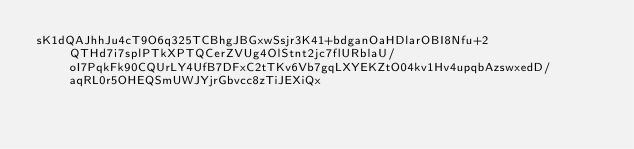<code> <loc_0><loc_0><loc_500><loc_500><_SML_>sK1dQAJhhJu4cT9O6q325TCBhgJBGxwSsjr3K41+bdganOaHDlarOBI8Nfu+2QTHd7i7splPTkXPTQCerZVUg4OlStnt2jc7flURblaU/oI7PqkFk90CQUrLY4UfB7DFxC2tTKv6Vb7gqLXYEKZtO04kv1Hv4upqbAzswxedD/aqRL0r5OHEQSmUWJYjrGbvcc8zTiJEXiQx</code> 